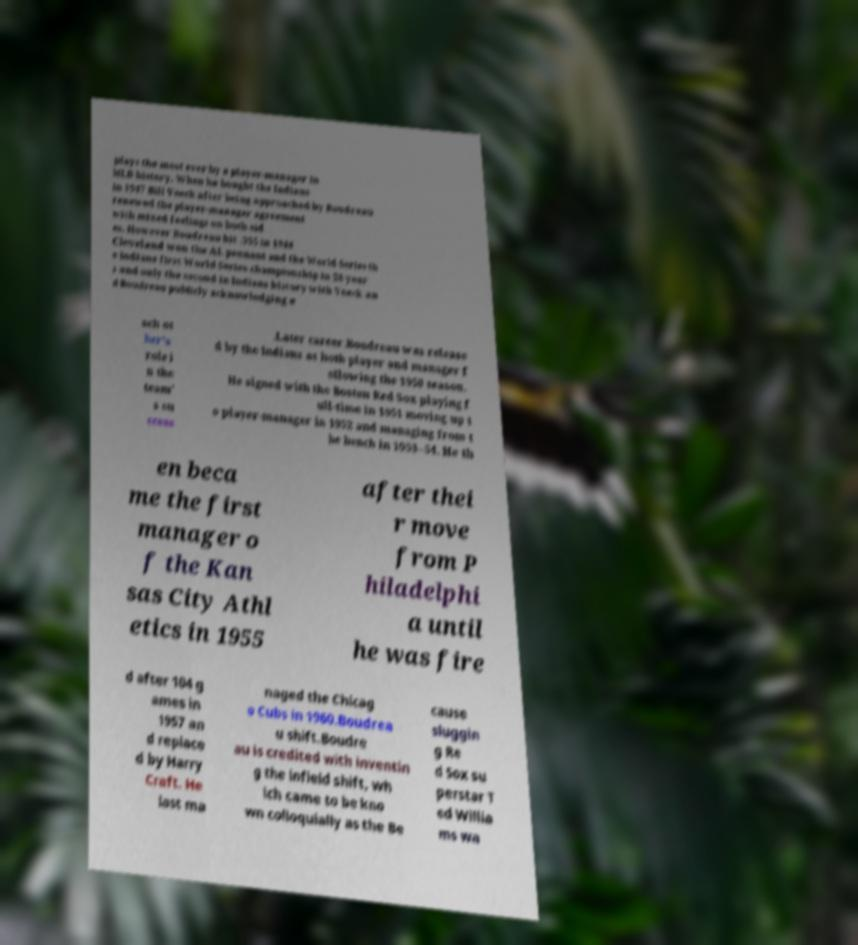Please identify and transcribe the text found in this image. plays the most ever by a player-manager in MLB history. When he bought the Indians in 1947 Bill Veeck after being approached by Boudreau renewed the player-manager agreement with mixed feelings on both sid es. However Boudreau hit .355 in 1948 Cleveland won the AL pennant and the World Series th e Indians first World Series championship in 28 year s and only the second in Indians history with Veeck an d Boudreau publicly acknowledging e ach ot her's role i n the team' s su ccess .Later career.Boudreau was release d by the Indians as both player and manager f ollowing the 1950 season. He signed with the Boston Red Sox playing f ull-time in 1951 moving up t o player-manager in 1952 and managing from t he bench in 1953–54. He th en beca me the first manager o f the Kan sas City Athl etics in 1955 after thei r move from P hiladelphi a until he was fire d after 104 g ames in 1957 an d replace d by Harry Craft. He last ma naged the Chicag o Cubs in 1960.Boudrea u shift.Boudre au is credited with inventin g the infield shift, wh ich came to be kno wn colloquially as the Be cause sluggin g Re d Sox su perstar T ed Willia ms wa 